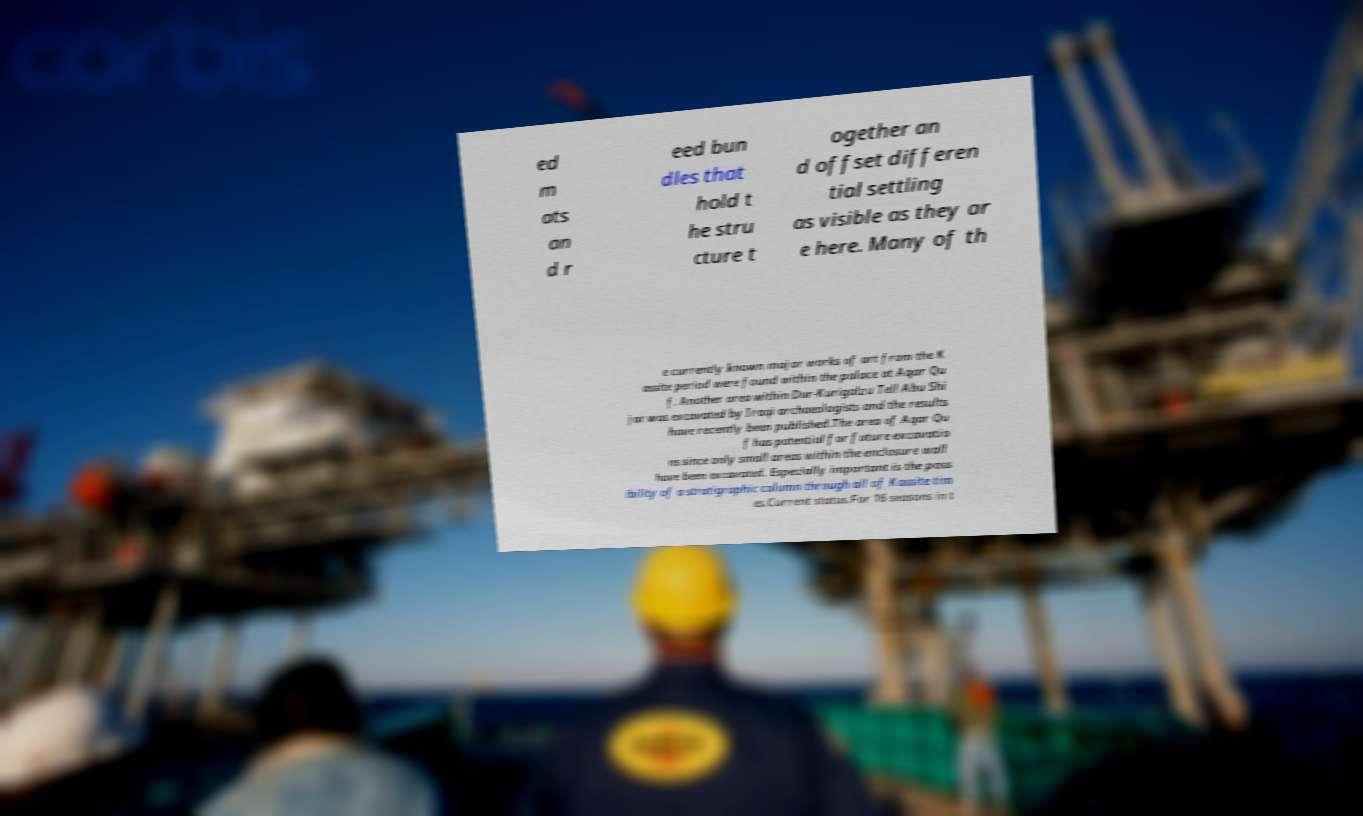I need the written content from this picture converted into text. Can you do that? ed m ats an d r eed bun dles that hold t he stru cture t ogether an d offset differen tial settling as visible as they ar e here. Many of th e currently known major works of art from the K assite period were found within the palace at Aqar Qu f. Another area within Dur-Kurigalzu Tell Abu Shi jar was excavated by Iraqi archaeologists and the results have recently been published.The area of Aqar Qu f has potential for future excavatio ns since only small areas within the enclosure wall have been excavated. Especially important is the poss ibility of a stratigraphic column through all of Kassite tim es.Current status.For 16 seasons in t 